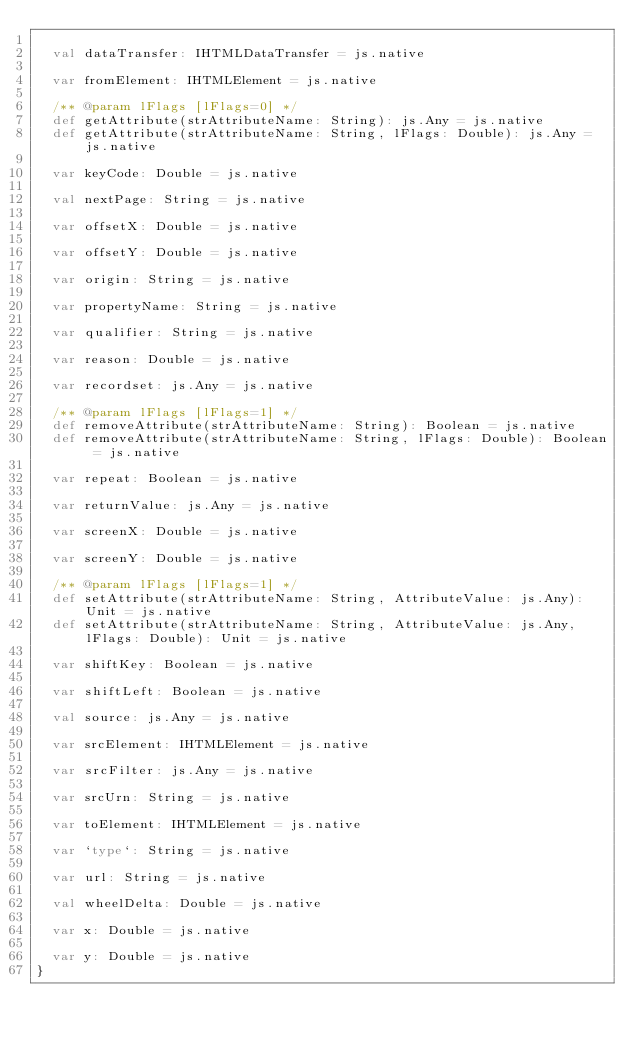Convert code to text. <code><loc_0><loc_0><loc_500><loc_500><_Scala_>  
  val dataTransfer: IHTMLDataTransfer = js.native
  
  var fromElement: IHTMLElement = js.native
  
  /** @param lFlags [lFlags=0] */
  def getAttribute(strAttributeName: String): js.Any = js.native
  def getAttribute(strAttributeName: String, lFlags: Double): js.Any = js.native
  
  var keyCode: Double = js.native
  
  val nextPage: String = js.native
  
  var offsetX: Double = js.native
  
  var offsetY: Double = js.native
  
  var origin: String = js.native
  
  var propertyName: String = js.native
  
  var qualifier: String = js.native
  
  var reason: Double = js.native
  
  var recordset: js.Any = js.native
  
  /** @param lFlags [lFlags=1] */
  def removeAttribute(strAttributeName: String): Boolean = js.native
  def removeAttribute(strAttributeName: String, lFlags: Double): Boolean = js.native
  
  var repeat: Boolean = js.native
  
  var returnValue: js.Any = js.native
  
  var screenX: Double = js.native
  
  var screenY: Double = js.native
  
  /** @param lFlags [lFlags=1] */
  def setAttribute(strAttributeName: String, AttributeValue: js.Any): Unit = js.native
  def setAttribute(strAttributeName: String, AttributeValue: js.Any, lFlags: Double): Unit = js.native
  
  var shiftKey: Boolean = js.native
  
  var shiftLeft: Boolean = js.native
  
  val source: js.Any = js.native
  
  var srcElement: IHTMLElement = js.native
  
  var srcFilter: js.Any = js.native
  
  var srcUrn: String = js.native
  
  var toElement: IHTMLElement = js.native
  
  var `type`: String = js.native
  
  var url: String = js.native
  
  val wheelDelta: Double = js.native
  
  var x: Double = js.native
  
  var y: Double = js.native
}
</code> 